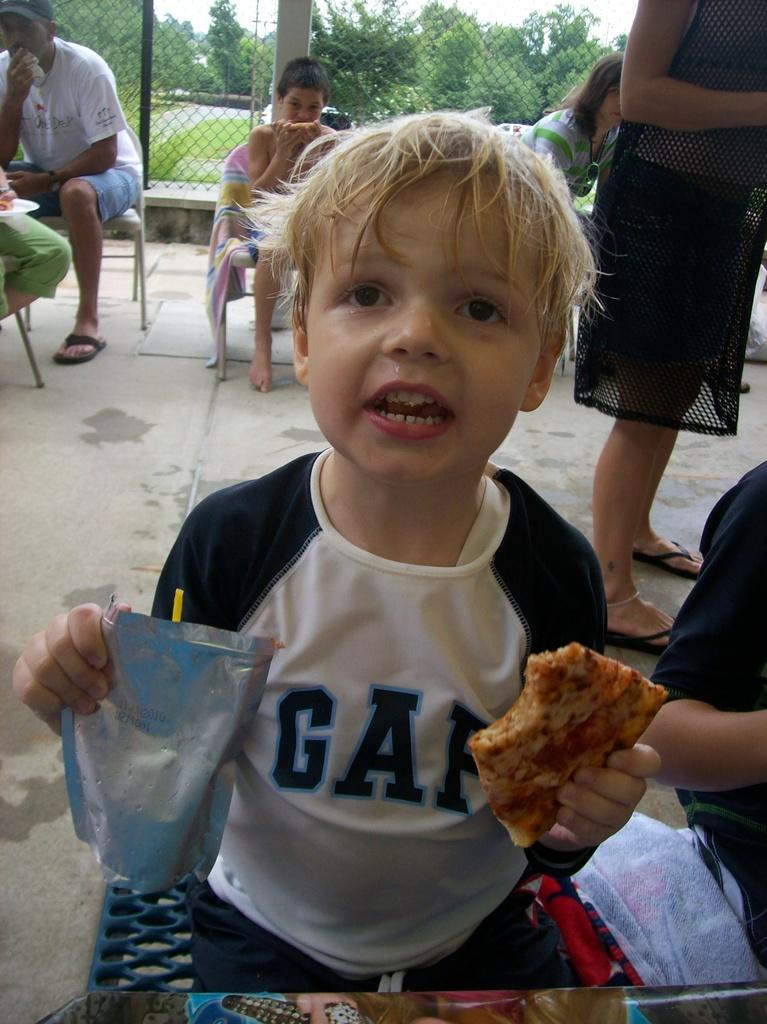What are the people in the image doing? The people in the image are sitting and eating. What can be seen in the background of the image? There is fencing, trees, and grass visible in the image. What verse is the grandmother reciting in the image? There is no grandmother or verse present in the image. 